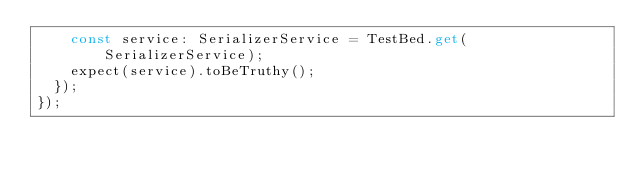<code> <loc_0><loc_0><loc_500><loc_500><_TypeScript_>    const service: SerializerService = TestBed.get(SerializerService);
    expect(service).toBeTruthy();
  });
});
</code> 